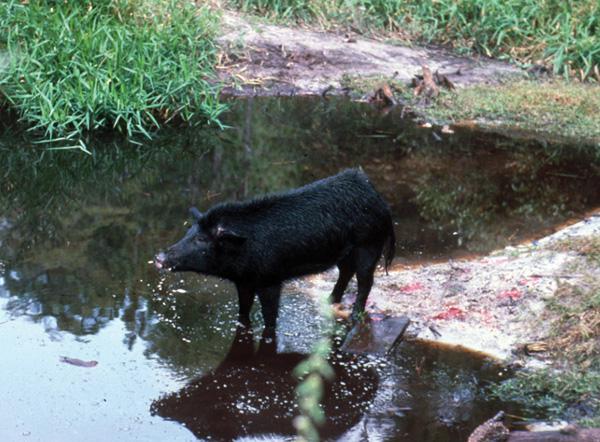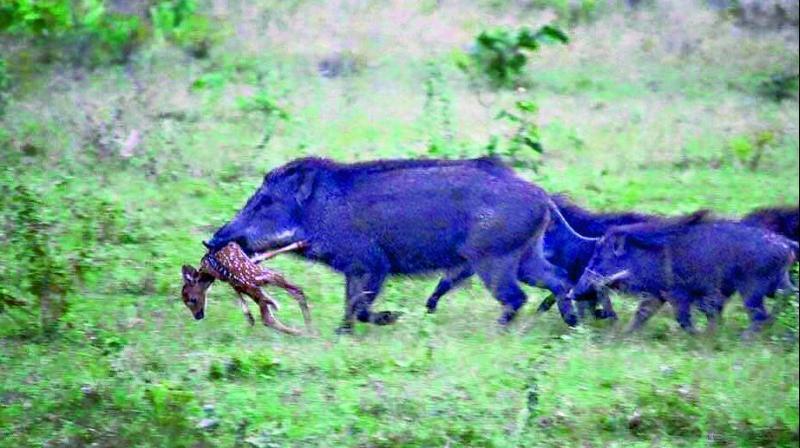The first image is the image on the left, the second image is the image on the right. For the images shown, is this caption "There are two pigs." true? Answer yes or no. No. The first image is the image on the left, the second image is the image on the right. For the images shown, is this caption "a lone wartgog is standing in the water" true? Answer yes or no. Yes. 